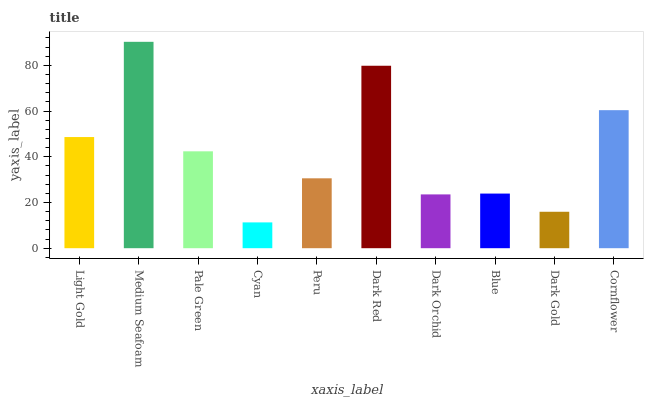Is Cyan the minimum?
Answer yes or no. Yes. Is Medium Seafoam the maximum?
Answer yes or no. Yes. Is Pale Green the minimum?
Answer yes or no. No. Is Pale Green the maximum?
Answer yes or no. No. Is Medium Seafoam greater than Pale Green?
Answer yes or no. Yes. Is Pale Green less than Medium Seafoam?
Answer yes or no. Yes. Is Pale Green greater than Medium Seafoam?
Answer yes or no. No. Is Medium Seafoam less than Pale Green?
Answer yes or no. No. Is Pale Green the high median?
Answer yes or no. Yes. Is Peru the low median?
Answer yes or no. Yes. Is Dark Red the high median?
Answer yes or no. No. Is Cyan the low median?
Answer yes or no. No. 